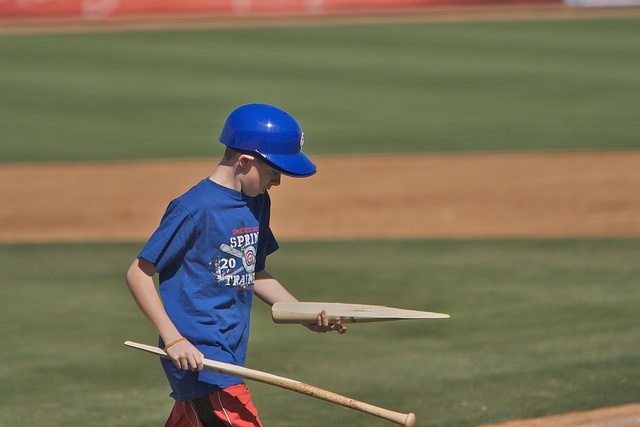Describe the objects in this image and their specific colors. I can see people in salmon, blue, black, gray, and navy tones and baseball bat in salmon and tan tones in this image. 